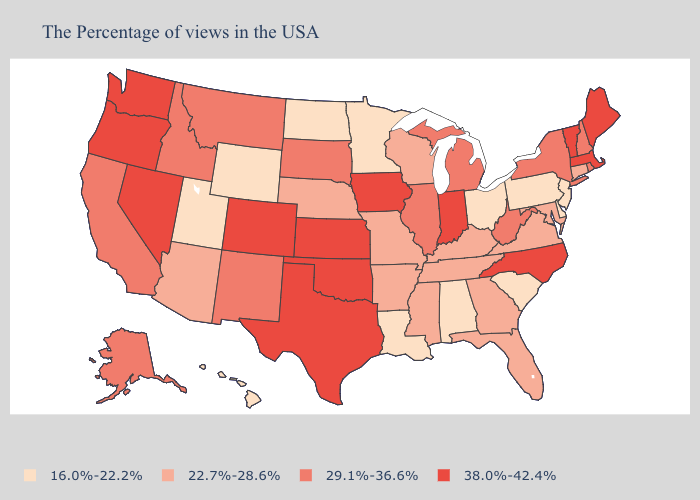Does Oklahoma have the same value as Arkansas?
Keep it brief. No. What is the lowest value in states that border Wisconsin?
Keep it brief. 16.0%-22.2%. What is the lowest value in the Northeast?
Keep it brief. 16.0%-22.2%. What is the highest value in the USA?
Be succinct. 38.0%-42.4%. Does the map have missing data?
Keep it brief. No. Is the legend a continuous bar?
Quick response, please. No. Name the states that have a value in the range 29.1%-36.6%?
Short answer required. Rhode Island, New Hampshire, New York, West Virginia, Michigan, Illinois, South Dakota, New Mexico, Montana, Idaho, California, Alaska. What is the value of Oklahoma?
Short answer required. 38.0%-42.4%. Which states have the lowest value in the South?
Concise answer only. Delaware, South Carolina, Alabama, Louisiana. What is the value of Louisiana?
Short answer required. 16.0%-22.2%. Does Hawaii have the lowest value in the USA?
Give a very brief answer. Yes. Does Hawaii have the lowest value in the West?
Write a very short answer. Yes. What is the value of Michigan?
Be succinct. 29.1%-36.6%. Which states have the lowest value in the USA?
Quick response, please. New Jersey, Delaware, Pennsylvania, South Carolina, Ohio, Alabama, Louisiana, Minnesota, North Dakota, Wyoming, Utah, Hawaii. Name the states that have a value in the range 29.1%-36.6%?
Keep it brief. Rhode Island, New Hampshire, New York, West Virginia, Michigan, Illinois, South Dakota, New Mexico, Montana, Idaho, California, Alaska. 